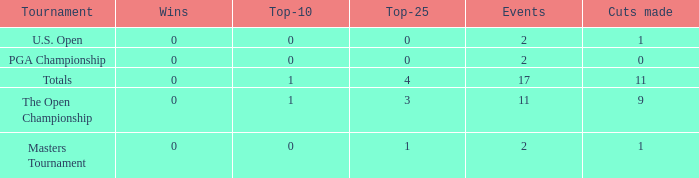What is his highest number of top 25s when eh played over 2 events and under 0 wins? None. 